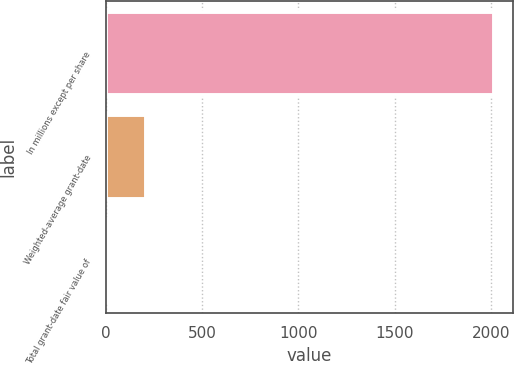<chart> <loc_0><loc_0><loc_500><loc_500><bar_chart><fcel>In millions except per share<fcel>Weighted-average grant-date<fcel>Total grant-date fair value of<nl><fcel>2015<fcel>204.65<fcel>3.5<nl></chart> 